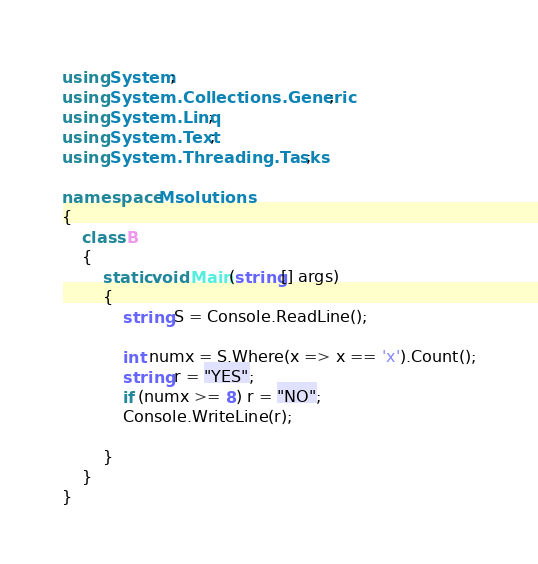<code> <loc_0><loc_0><loc_500><loc_500><_C#_>using System;
using System.Collections.Generic;
using System.Linq;
using System.Text;
using System.Threading.Tasks;

namespace Msolutions
{
    class B
    {
        static void Main(string[] args)
        {
            string S = Console.ReadLine();

            int numx = S.Where(x => x == 'x').Count();
            string r = "YES";
            if (numx >= 8) r = "NO";
            Console.WriteLine(r);

        }
    }
}
</code> 